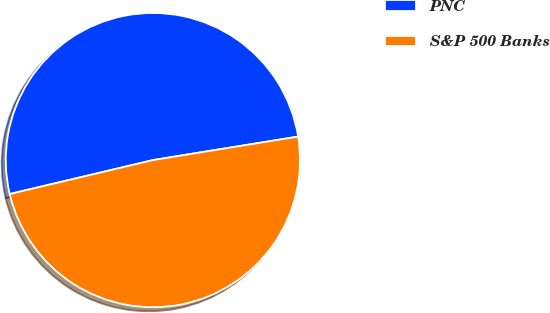Convert chart. <chart><loc_0><loc_0><loc_500><loc_500><pie_chart><fcel>PNC<fcel>S&P 500 Banks<nl><fcel>51.15%<fcel>48.85%<nl></chart> 